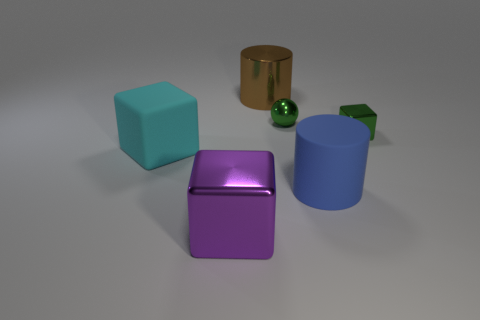What number of green objects are either cylinders or small metallic blocks?
Make the answer very short. 1. What material is the cylinder in front of the large shiny cylinder?
Your answer should be compact. Rubber. Is the material of the big purple thing in front of the tiny green cube the same as the green block?
Offer a terse response. Yes. The big cyan rubber thing has what shape?
Offer a terse response. Cube. There is a metallic block that is behind the rubber thing on the right side of the brown object; what number of large blue matte things are in front of it?
Your response must be concise. 1. What number of other things are there of the same material as the large purple cube
Your answer should be very brief. 3. What material is the cyan cube that is the same size as the blue matte cylinder?
Provide a succinct answer. Rubber. There is a metallic block to the left of the brown thing; is it the same color as the small metallic object behind the green cube?
Offer a terse response. No. Are there any blue matte objects that have the same shape as the purple metal object?
Your answer should be compact. No. There is a metallic thing that is the same size as the green sphere; what is its shape?
Provide a succinct answer. Cube. 